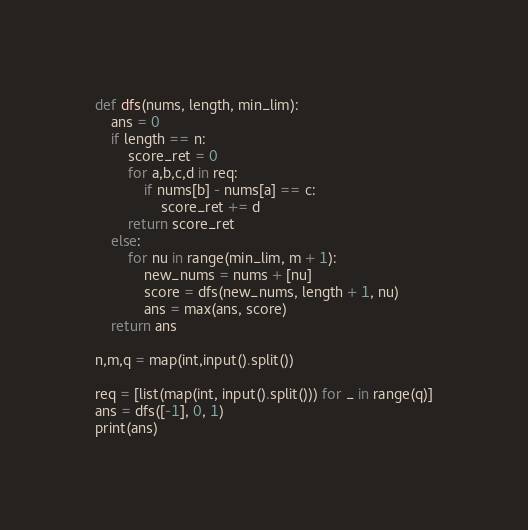<code> <loc_0><loc_0><loc_500><loc_500><_Python_>def dfs(nums, length, min_lim):
    ans = 0
    if length == n:
        score_ret = 0
        for a,b,c,d in req:
            if nums[b] - nums[a] == c:
                score_ret += d
        return score_ret
    else:
        for nu in range(min_lim, m + 1):
            new_nums = nums + [nu]
            score = dfs(new_nums, length + 1, nu)
            ans = max(ans, score)
    return ans

n,m,q = map(int,input().split())

req = [list(map(int, input().split())) for _ in range(q)]
ans = dfs([-1], 0, 1)
print(ans)</code> 